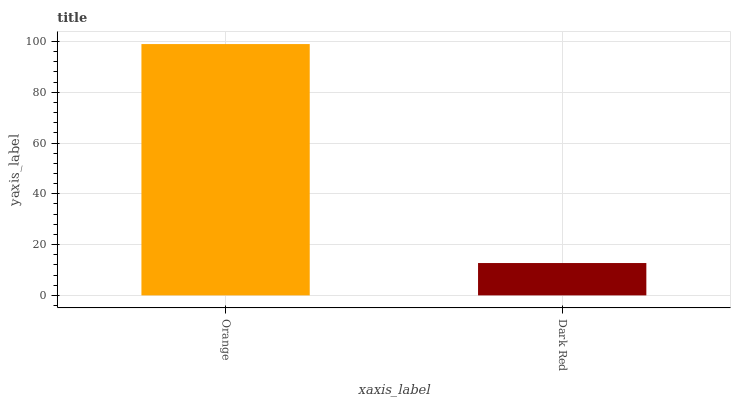Is Dark Red the minimum?
Answer yes or no. Yes. Is Orange the maximum?
Answer yes or no. Yes. Is Dark Red the maximum?
Answer yes or no. No. Is Orange greater than Dark Red?
Answer yes or no. Yes. Is Dark Red less than Orange?
Answer yes or no. Yes. Is Dark Red greater than Orange?
Answer yes or no. No. Is Orange less than Dark Red?
Answer yes or no. No. Is Orange the high median?
Answer yes or no. Yes. Is Dark Red the low median?
Answer yes or no. Yes. Is Dark Red the high median?
Answer yes or no. No. Is Orange the low median?
Answer yes or no. No. 